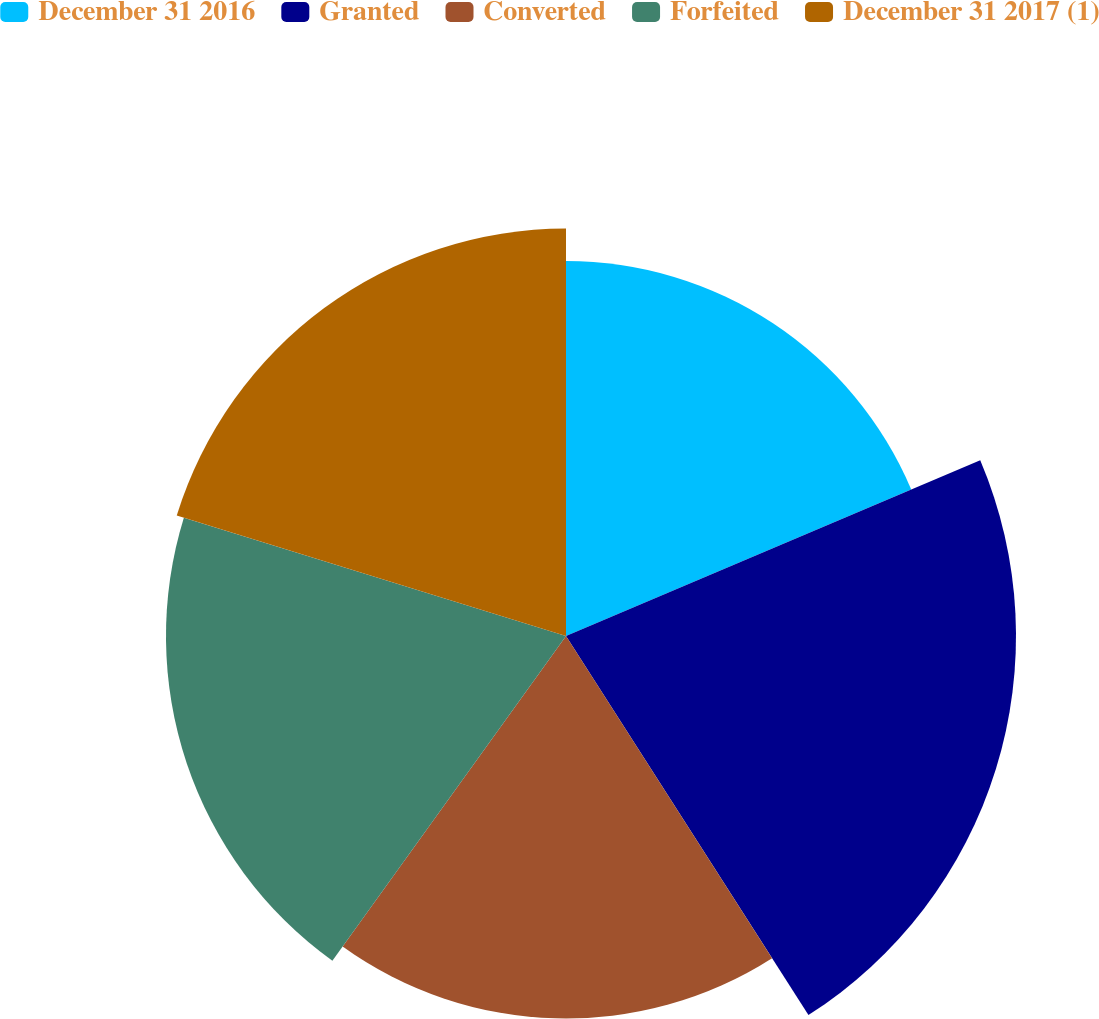<chart> <loc_0><loc_0><loc_500><loc_500><pie_chart><fcel>December 31 2016<fcel>Granted<fcel>Converted<fcel>Forfeited<fcel>December 31 2017 (1)<nl><fcel>18.61%<fcel>22.33%<fcel>18.98%<fcel>19.85%<fcel>20.22%<nl></chart> 